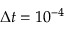<formula> <loc_0><loc_0><loc_500><loc_500>\Delta t = 1 0 ^ { - 4 }</formula> 